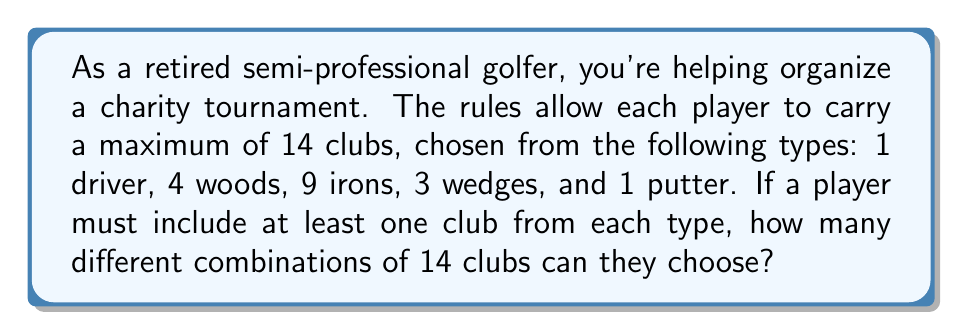What is the answer to this math problem? Let's approach this step-by-step:

1) First, we need to ensure one club from each type is included. This leaves us with 9 more clubs to choose:
   - 1 driver (already included)
   - 3 woods left to choose from
   - 8 irons left to choose from
   - 2 wedges left to choose from
   - 1 putter (already included)

2) Now, we need to choose 9 clubs from the remaining 13 (3 + 8 + 2) to make up the 14 total.

3) This is a combination problem with repetition allowed, as we can choose multiple clubs of the same type.

4) The formula for combinations with repetition is:

   $$ \binom{n+r-1}{r} = \binom{n+r-1}{n-1} $$

   Where $n$ is the number of types to choose from (in this case, 3: woods, irons, and wedges) and $r$ is the number of items to be chosen (9).

5) Plugging in our values:

   $$ \binom{3+9-1}{9} = \binom{11}{9} = \binom{11}{2} $$

6) We can calculate this:

   $$ \binom{11}{2} = \frac{11!}{2!(11-2)!} = \frac{11 \cdot 10}{2 \cdot 1} = 55 $$

Therefore, there are 55 different ways to choose the 14 clubs.
Answer: 55 